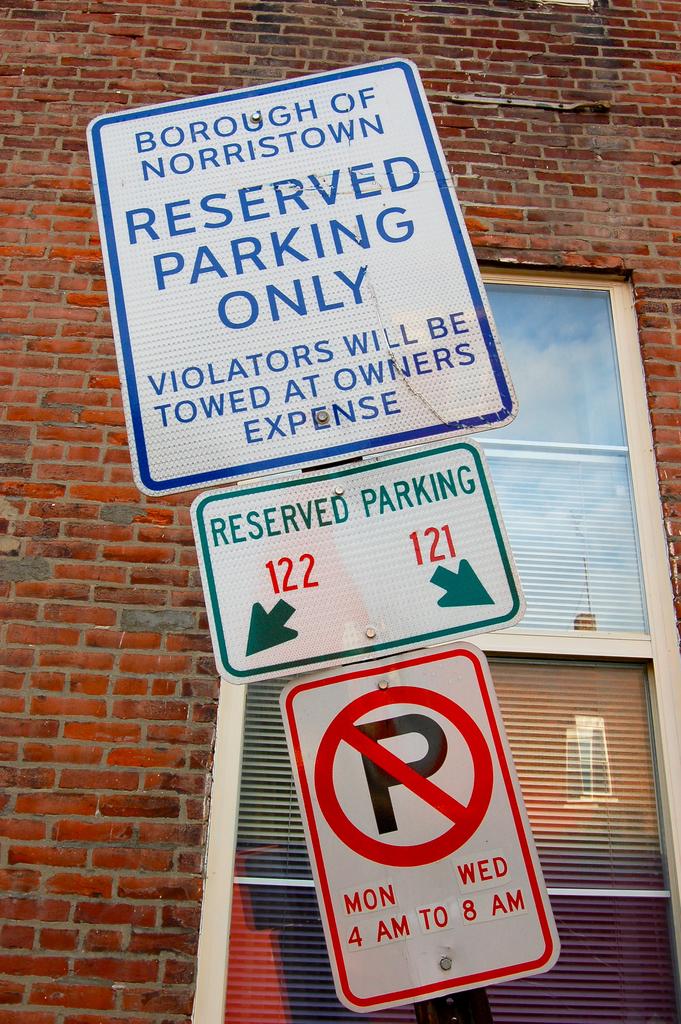When can you park int he no parking zone?
Offer a terse response. When you have the reserved parking spot . 